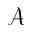<formula> <loc_0><loc_0><loc_500><loc_500>\mathcal { A }</formula> 